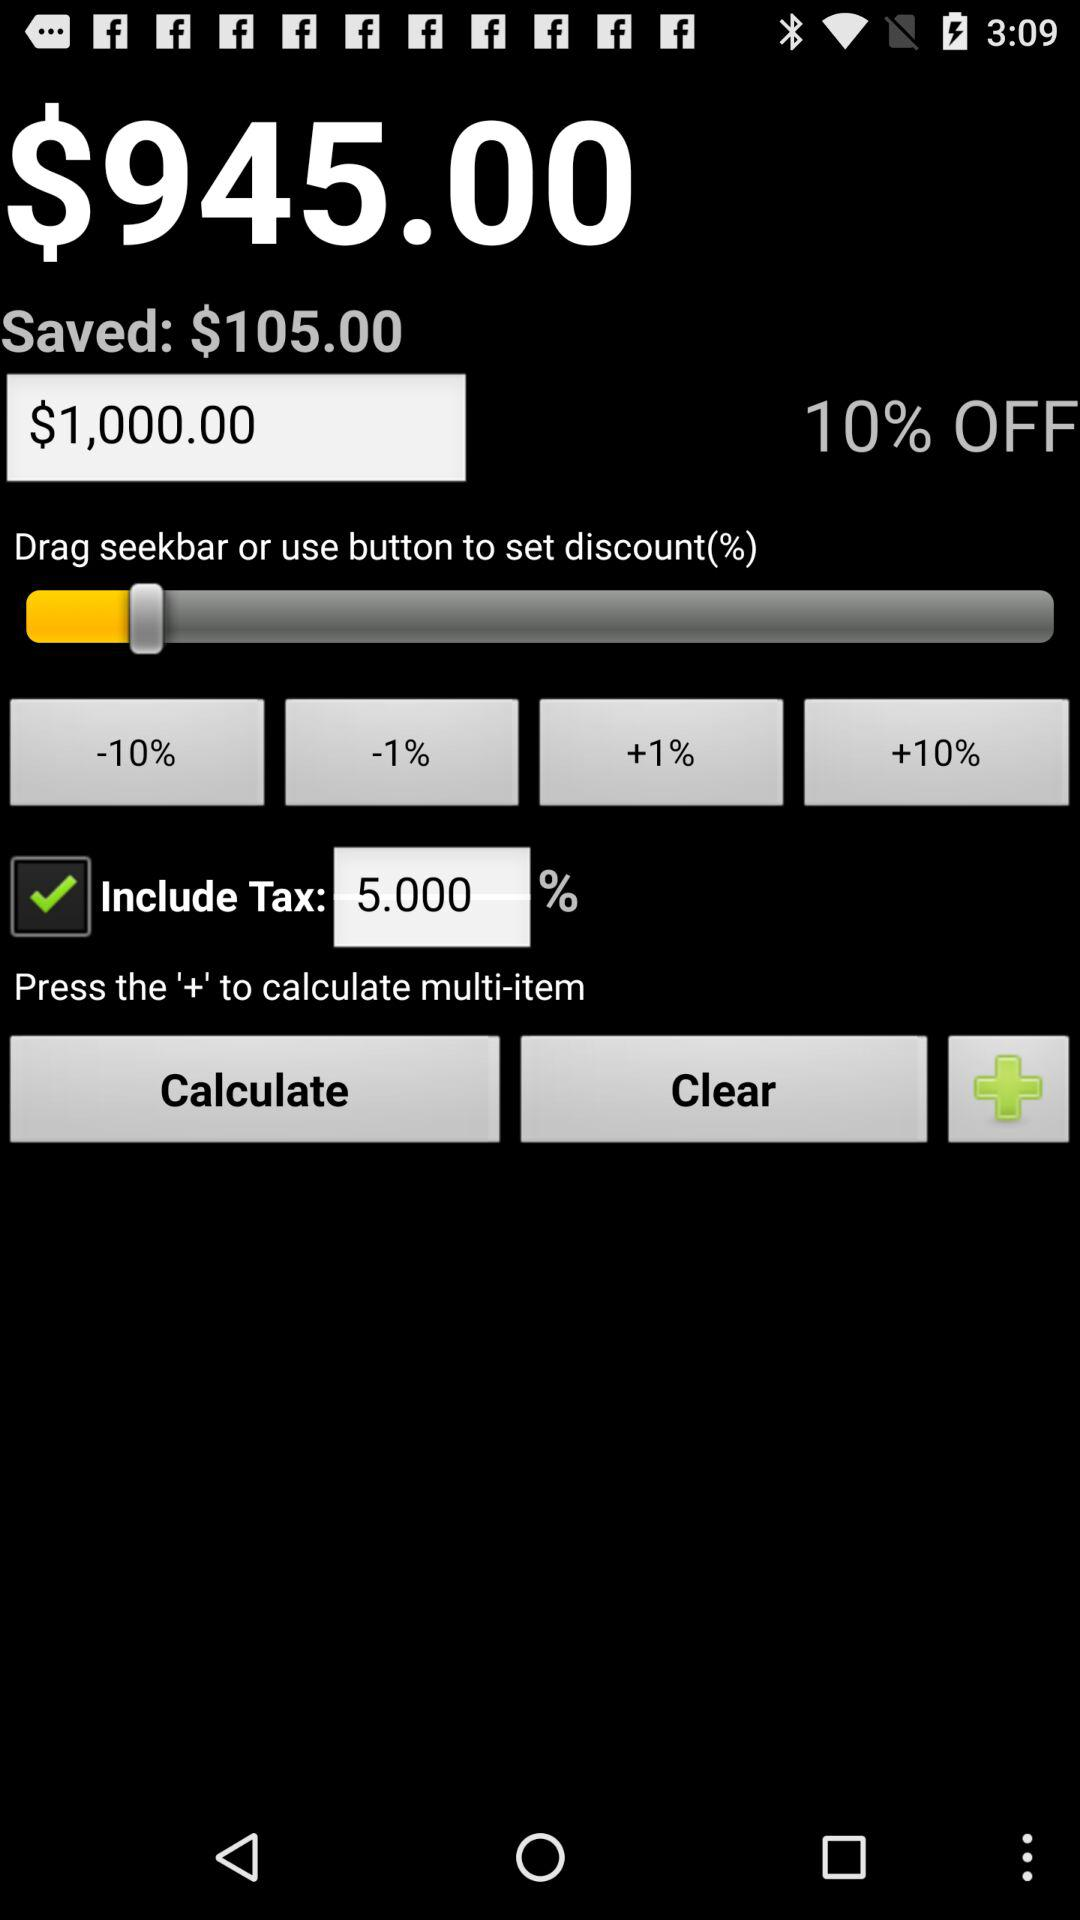Is "Include Tax" checked or not? "Include Tax" is checked. 